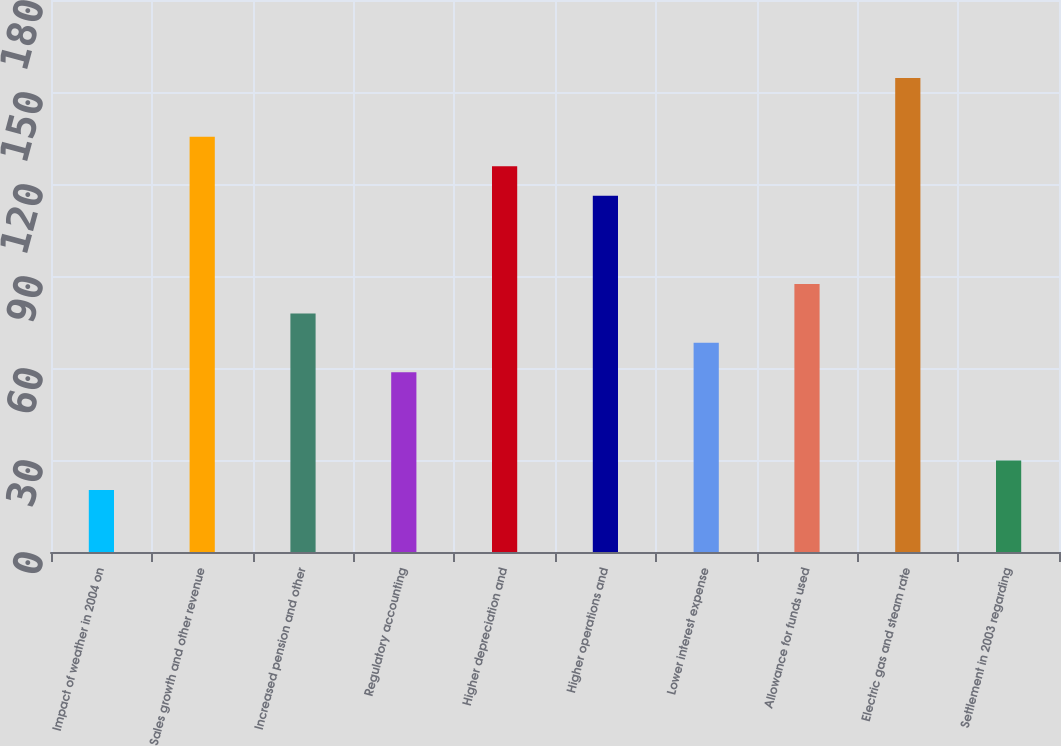Convert chart. <chart><loc_0><loc_0><loc_500><loc_500><bar_chart><fcel>Impact of weather in 2004 on<fcel>Sales growth and other revenue<fcel>Increased pension and other<fcel>Regulatory accounting<fcel>Higher depreciation and<fcel>Higher operations and<fcel>Lower interest expense<fcel>Allowance for funds used<fcel>Electric gas and steam rate<fcel>Settlement in 2003 regarding<nl><fcel>20.2<fcel>135.4<fcel>77.8<fcel>58.6<fcel>125.8<fcel>116.2<fcel>68.2<fcel>87.4<fcel>154.6<fcel>29.8<nl></chart> 